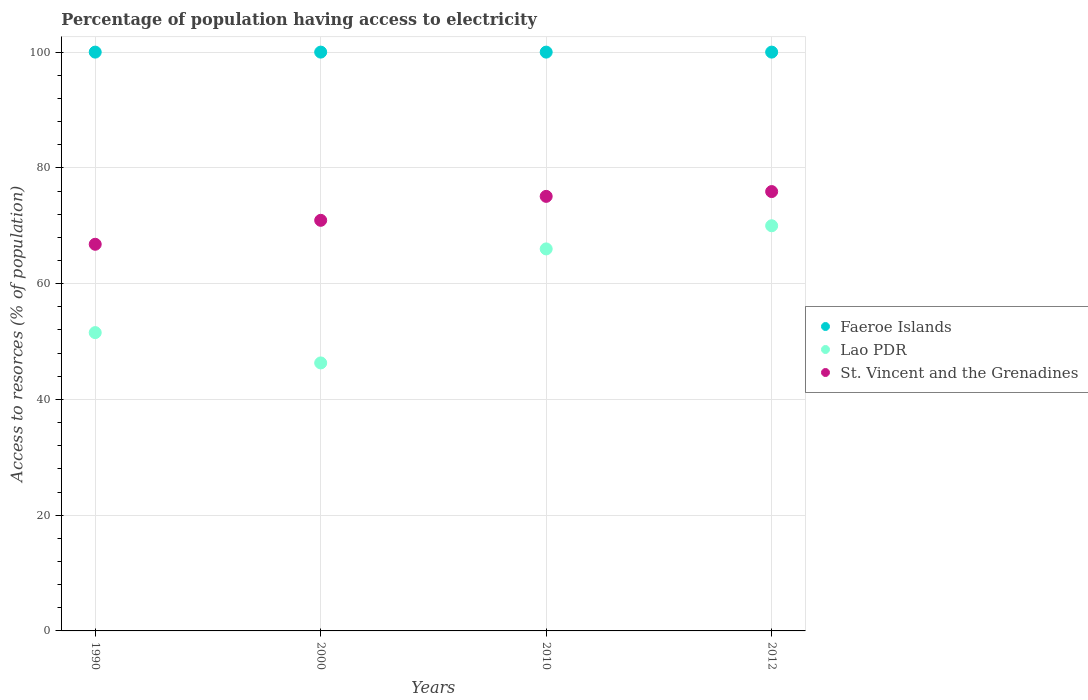How many different coloured dotlines are there?
Ensure brevity in your answer.  3. What is the percentage of population having access to electricity in St. Vincent and the Grenadines in 2000?
Offer a very short reply. 70.94. Across all years, what is the maximum percentage of population having access to electricity in St. Vincent and the Grenadines?
Provide a short and direct response. 75.91. Across all years, what is the minimum percentage of population having access to electricity in Faeroe Islands?
Provide a short and direct response. 100. What is the total percentage of population having access to electricity in Lao PDR in the graph?
Offer a very short reply. 233.84. What is the difference between the percentage of population having access to electricity in St. Vincent and the Grenadines in 2000 and the percentage of population having access to electricity in Lao PDR in 2010?
Give a very brief answer. 4.94. What is the average percentage of population having access to electricity in Lao PDR per year?
Give a very brief answer. 58.46. In the year 2012, what is the difference between the percentage of population having access to electricity in Faeroe Islands and percentage of population having access to electricity in St. Vincent and the Grenadines?
Your response must be concise. 24.09. Is the percentage of population having access to electricity in St. Vincent and the Grenadines in 1990 less than that in 2010?
Offer a very short reply. Yes. Is the difference between the percentage of population having access to electricity in Faeroe Islands in 2000 and 2012 greater than the difference between the percentage of population having access to electricity in St. Vincent and the Grenadines in 2000 and 2012?
Your response must be concise. Yes. What is the difference between the highest and the second highest percentage of population having access to electricity in Faeroe Islands?
Your response must be concise. 0. Is it the case that in every year, the sum of the percentage of population having access to electricity in Faeroe Islands and percentage of population having access to electricity in Lao PDR  is greater than the percentage of population having access to electricity in St. Vincent and the Grenadines?
Make the answer very short. Yes. Does the percentage of population having access to electricity in Faeroe Islands monotonically increase over the years?
Your answer should be compact. No. Is the percentage of population having access to electricity in St. Vincent and the Grenadines strictly less than the percentage of population having access to electricity in Faeroe Islands over the years?
Ensure brevity in your answer.  Yes. Does the graph contain any zero values?
Your answer should be compact. No. Does the graph contain grids?
Offer a terse response. Yes. Where does the legend appear in the graph?
Offer a very short reply. Center right. How many legend labels are there?
Offer a terse response. 3. How are the legend labels stacked?
Offer a very short reply. Vertical. What is the title of the graph?
Offer a very short reply. Percentage of population having access to electricity. Does "Brunei Darussalam" appear as one of the legend labels in the graph?
Offer a very short reply. No. What is the label or title of the X-axis?
Make the answer very short. Years. What is the label or title of the Y-axis?
Provide a succinct answer. Access to resorces (% of population). What is the Access to resorces (% of population) of Lao PDR in 1990?
Your answer should be compact. 51.54. What is the Access to resorces (% of population) of St. Vincent and the Grenadines in 1990?
Give a very brief answer. 66.8. What is the Access to resorces (% of population) in Lao PDR in 2000?
Your answer should be very brief. 46.3. What is the Access to resorces (% of population) of St. Vincent and the Grenadines in 2000?
Your answer should be compact. 70.94. What is the Access to resorces (% of population) of Lao PDR in 2010?
Provide a succinct answer. 66. What is the Access to resorces (% of population) in St. Vincent and the Grenadines in 2010?
Keep it short and to the point. 75.08. What is the Access to resorces (% of population) of St. Vincent and the Grenadines in 2012?
Offer a terse response. 75.91. Across all years, what is the maximum Access to resorces (% of population) in Faeroe Islands?
Offer a very short reply. 100. Across all years, what is the maximum Access to resorces (% of population) in St. Vincent and the Grenadines?
Keep it short and to the point. 75.91. Across all years, what is the minimum Access to resorces (% of population) in Lao PDR?
Make the answer very short. 46.3. Across all years, what is the minimum Access to resorces (% of population) in St. Vincent and the Grenadines?
Your response must be concise. 66.8. What is the total Access to resorces (% of population) of Lao PDR in the graph?
Your answer should be very brief. 233.84. What is the total Access to resorces (% of population) of St. Vincent and the Grenadines in the graph?
Provide a succinct answer. 288.72. What is the difference between the Access to resorces (% of population) in Faeroe Islands in 1990 and that in 2000?
Your response must be concise. 0. What is the difference between the Access to resorces (% of population) of Lao PDR in 1990 and that in 2000?
Provide a succinct answer. 5.24. What is the difference between the Access to resorces (% of population) in St. Vincent and the Grenadines in 1990 and that in 2000?
Give a very brief answer. -4.14. What is the difference between the Access to resorces (% of population) of Faeroe Islands in 1990 and that in 2010?
Provide a succinct answer. 0. What is the difference between the Access to resorces (% of population) in Lao PDR in 1990 and that in 2010?
Make the answer very short. -14.46. What is the difference between the Access to resorces (% of population) of St. Vincent and the Grenadines in 1990 and that in 2010?
Your answer should be compact. -8.28. What is the difference between the Access to resorces (% of population) in Lao PDR in 1990 and that in 2012?
Your answer should be compact. -18.46. What is the difference between the Access to resorces (% of population) of St. Vincent and the Grenadines in 1990 and that in 2012?
Ensure brevity in your answer.  -9.11. What is the difference between the Access to resorces (% of population) in Lao PDR in 2000 and that in 2010?
Provide a short and direct response. -19.7. What is the difference between the Access to resorces (% of population) in St. Vincent and the Grenadines in 2000 and that in 2010?
Make the answer very short. -4.14. What is the difference between the Access to resorces (% of population) of Lao PDR in 2000 and that in 2012?
Make the answer very short. -23.7. What is the difference between the Access to resorces (% of population) in St. Vincent and the Grenadines in 2000 and that in 2012?
Offer a very short reply. -4.97. What is the difference between the Access to resorces (% of population) in Faeroe Islands in 2010 and that in 2012?
Give a very brief answer. 0. What is the difference between the Access to resorces (% of population) of St. Vincent and the Grenadines in 2010 and that in 2012?
Your answer should be compact. -0.83. What is the difference between the Access to resorces (% of population) of Faeroe Islands in 1990 and the Access to resorces (% of population) of Lao PDR in 2000?
Ensure brevity in your answer.  53.7. What is the difference between the Access to resorces (% of population) of Faeroe Islands in 1990 and the Access to resorces (% of population) of St. Vincent and the Grenadines in 2000?
Offer a very short reply. 29.06. What is the difference between the Access to resorces (% of population) in Lao PDR in 1990 and the Access to resorces (% of population) in St. Vincent and the Grenadines in 2000?
Your response must be concise. -19.4. What is the difference between the Access to resorces (% of population) in Faeroe Islands in 1990 and the Access to resorces (% of population) in Lao PDR in 2010?
Offer a terse response. 34. What is the difference between the Access to resorces (% of population) of Faeroe Islands in 1990 and the Access to resorces (% of population) of St. Vincent and the Grenadines in 2010?
Keep it short and to the point. 24.92. What is the difference between the Access to resorces (% of population) of Lao PDR in 1990 and the Access to resorces (% of population) of St. Vincent and the Grenadines in 2010?
Give a very brief answer. -23.54. What is the difference between the Access to resorces (% of population) in Faeroe Islands in 1990 and the Access to resorces (% of population) in Lao PDR in 2012?
Keep it short and to the point. 30. What is the difference between the Access to resorces (% of population) in Faeroe Islands in 1990 and the Access to resorces (% of population) in St. Vincent and the Grenadines in 2012?
Make the answer very short. 24.09. What is the difference between the Access to resorces (% of population) in Lao PDR in 1990 and the Access to resorces (% of population) in St. Vincent and the Grenadines in 2012?
Keep it short and to the point. -24.37. What is the difference between the Access to resorces (% of population) in Faeroe Islands in 2000 and the Access to resorces (% of population) in St. Vincent and the Grenadines in 2010?
Your response must be concise. 24.92. What is the difference between the Access to resorces (% of population) in Lao PDR in 2000 and the Access to resorces (% of population) in St. Vincent and the Grenadines in 2010?
Provide a succinct answer. -28.78. What is the difference between the Access to resorces (% of population) of Faeroe Islands in 2000 and the Access to resorces (% of population) of St. Vincent and the Grenadines in 2012?
Your answer should be compact. 24.09. What is the difference between the Access to resorces (% of population) of Lao PDR in 2000 and the Access to resorces (% of population) of St. Vincent and the Grenadines in 2012?
Ensure brevity in your answer.  -29.61. What is the difference between the Access to resorces (% of population) of Faeroe Islands in 2010 and the Access to resorces (% of population) of Lao PDR in 2012?
Your answer should be compact. 30. What is the difference between the Access to resorces (% of population) in Faeroe Islands in 2010 and the Access to resorces (% of population) in St. Vincent and the Grenadines in 2012?
Make the answer very short. 24.09. What is the difference between the Access to resorces (% of population) of Lao PDR in 2010 and the Access to resorces (% of population) of St. Vincent and the Grenadines in 2012?
Provide a succinct answer. -9.91. What is the average Access to resorces (% of population) in Faeroe Islands per year?
Keep it short and to the point. 100. What is the average Access to resorces (% of population) in Lao PDR per year?
Provide a succinct answer. 58.46. What is the average Access to resorces (% of population) in St. Vincent and the Grenadines per year?
Your response must be concise. 72.18. In the year 1990, what is the difference between the Access to resorces (% of population) of Faeroe Islands and Access to resorces (% of population) of Lao PDR?
Keep it short and to the point. 48.46. In the year 1990, what is the difference between the Access to resorces (% of population) of Faeroe Islands and Access to resorces (% of population) of St. Vincent and the Grenadines?
Keep it short and to the point. 33.2. In the year 1990, what is the difference between the Access to resorces (% of population) of Lao PDR and Access to resorces (% of population) of St. Vincent and the Grenadines?
Your answer should be very brief. -15.26. In the year 2000, what is the difference between the Access to resorces (% of population) in Faeroe Islands and Access to resorces (% of population) in Lao PDR?
Your answer should be compact. 53.7. In the year 2000, what is the difference between the Access to resorces (% of population) in Faeroe Islands and Access to resorces (% of population) in St. Vincent and the Grenadines?
Give a very brief answer. 29.06. In the year 2000, what is the difference between the Access to resorces (% of population) of Lao PDR and Access to resorces (% of population) of St. Vincent and the Grenadines?
Your response must be concise. -24.64. In the year 2010, what is the difference between the Access to resorces (% of population) in Faeroe Islands and Access to resorces (% of population) in Lao PDR?
Provide a succinct answer. 34. In the year 2010, what is the difference between the Access to resorces (% of population) in Faeroe Islands and Access to resorces (% of population) in St. Vincent and the Grenadines?
Provide a short and direct response. 24.92. In the year 2010, what is the difference between the Access to resorces (% of population) in Lao PDR and Access to resorces (% of population) in St. Vincent and the Grenadines?
Your answer should be very brief. -9.08. In the year 2012, what is the difference between the Access to resorces (% of population) of Faeroe Islands and Access to resorces (% of population) of Lao PDR?
Ensure brevity in your answer.  30. In the year 2012, what is the difference between the Access to resorces (% of population) of Faeroe Islands and Access to resorces (% of population) of St. Vincent and the Grenadines?
Offer a terse response. 24.09. In the year 2012, what is the difference between the Access to resorces (% of population) of Lao PDR and Access to resorces (% of population) of St. Vincent and the Grenadines?
Your answer should be compact. -5.91. What is the ratio of the Access to resorces (% of population) in Lao PDR in 1990 to that in 2000?
Keep it short and to the point. 1.11. What is the ratio of the Access to resorces (% of population) of St. Vincent and the Grenadines in 1990 to that in 2000?
Provide a short and direct response. 0.94. What is the ratio of the Access to resorces (% of population) in Faeroe Islands in 1990 to that in 2010?
Give a very brief answer. 1. What is the ratio of the Access to resorces (% of population) of Lao PDR in 1990 to that in 2010?
Keep it short and to the point. 0.78. What is the ratio of the Access to resorces (% of population) in St. Vincent and the Grenadines in 1990 to that in 2010?
Provide a succinct answer. 0.89. What is the ratio of the Access to resorces (% of population) of Lao PDR in 1990 to that in 2012?
Keep it short and to the point. 0.74. What is the ratio of the Access to resorces (% of population) in Faeroe Islands in 2000 to that in 2010?
Your answer should be very brief. 1. What is the ratio of the Access to resorces (% of population) in Lao PDR in 2000 to that in 2010?
Ensure brevity in your answer.  0.7. What is the ratio of the Access to resorces (% of population) in St. Vincent and the Grenadines in 2000 to that in 2010?
Provide a succinct answer. 0.94. What is the ratio of the Access to resorces (% of population) in Faeroe Islands in 2000 to that in 2012?
Make the answer very short. 1. What is the ratio of the Access to resorces (% of population) in Lao PDR in 2000 to that in 2012?
Your answer should be very brief. 0.66. What is the ratio of the Access to resorces (% of population) in St. Vincent and the Grenadines in 2000 to that in 2012?
Ensure brevity in your answer.  0.93. What is the ratio of the Access to resorces (% of population) of Faeroe Islands in 2010 to that in 2012?
Give a very brief answer. 1. What is the ratio of the Access to resorces (% of population) of Lao PDR in 2010 to that in 2012?
Your answer should be compact. 0.94. What is the ratio of the Access to resorces (% of population) of St. Vincent and the Grenadines in 2010 to that in 2012?
Give a very brief answer. 0.99. What is the difference between the highest and the second highest Access to resorces (% of population) in Lao PDR?
Offer a very short reply. 4. What is the difference between the highest and the second highest Access to resorces (% of population) of St. Vincent and the Grenadines?
Make the answer very short. 0.83. What is the difference between the highest and the lowest Access to resorces (% of population) of Faeroe Islands?
Provide a succinct answer. 0. What is the difference between the highest and the lowest Access to resorces (% of population) of Lao PDR?
Your answer should be very brief. 23.7. What is the difference between the highest and the lowest Access to resorces (% of population) in St. Vincent and the Grenadines?
Provide a short and direct response. 9.11. 